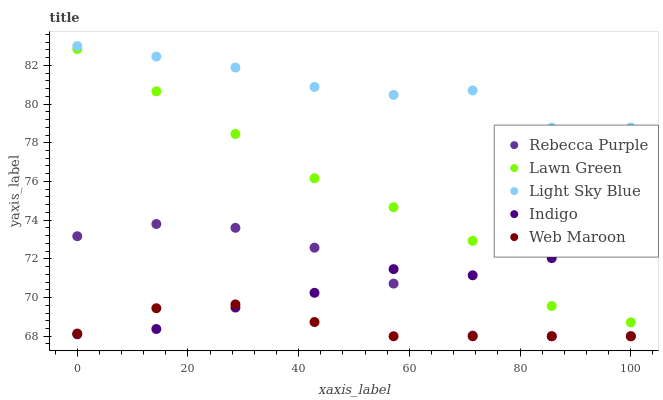Does Web Maroon have the minimum area under the curve?
Answer yes or no. Yes. Does Light Sky Blue have the maximum area under the curve?
Answer yes or no. Yes. Does Indigo have the minimum area under the curve?
Answer yes or no. No. Does Indigo have the maximum area under the curve?
Answer yes or no. No. Is Web Maroon the smoothest?
Answer yes or no. Yes. Is Rebecca Purple the roughest?
Answer yes or no. Yes. Is Light Sky Blue the smoothest?
Answer yes or no. No. Is Light Sky Blue the roughest?
Answer yes or no. No. Does Rebecca Purple have the lowest value?
Answer yes or no. Yes. Does Indigo have the lowest value?
Answer yes or no. No. Does Light Sky Blue have the highest value?
Answer yes or no. Yes. Does Indigo have the highest value?
Answer yes or no. No. Is Lawn Green less than Light Sky Blue?
Answer yes or no. Yes. Is Light Sky Blue greater than Rebecca Purple?
Answer yes or no. Yes. Does Indigo intersect Web Maroon?
Answer yes or no. Yes. Is Indigo less than Web Maroon?
Answer yes or no. No. Is Indigo greater than Web Maroon?
Answer yes or no. No. Does Lawn Green intersect Light Sky Blue?
Answer yes or no. No. 